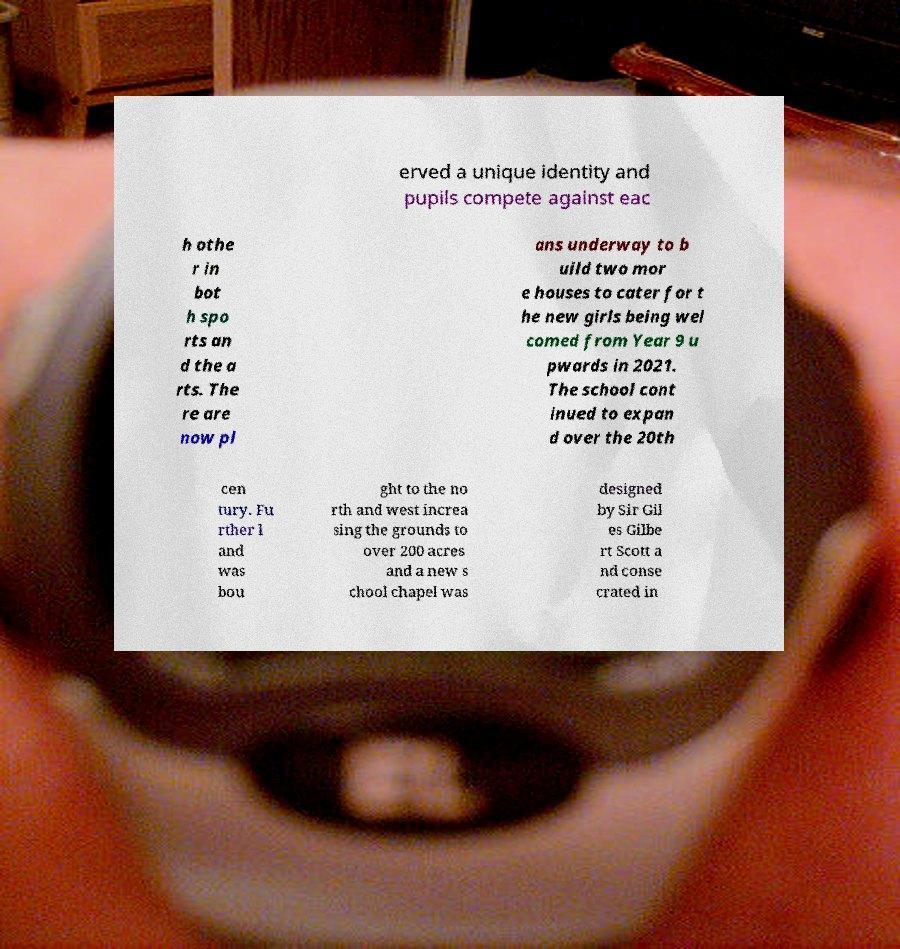There's text embedded in this image that I need extracted. Can you transcribe it verbatim? erved a unique identity and pupils compete against eac h othe r in bot h spo rts an d the a rts. The re are now pl ans underway to b uild two mor e houses to cater for t he new girls being wel comed from Year 9 u pwards in 2021. The school cont inued to expan d over the 20th cen tury. Fu rther l and was bou ght to the no rth and west increa sing the grounds to over 200 acres and a new s chool chapel was designed by Sir Gil es Gilbe rt Scott a nd conse crated in 